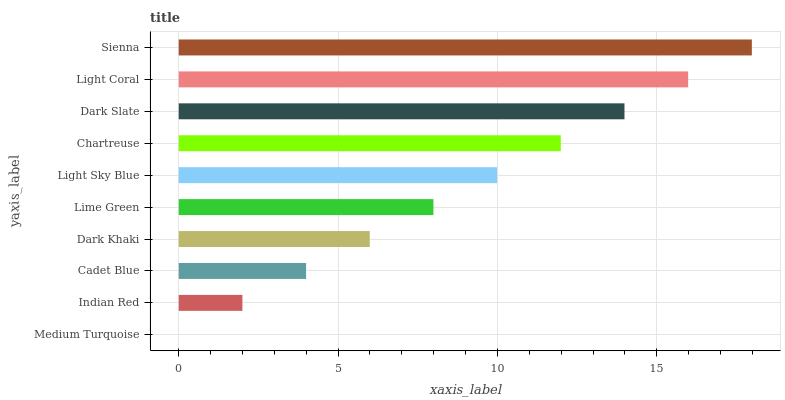Is Medium Turquoise the minimum?
Answer yes or no. Yes. Is Sienna the maximum?
Answer yes or no. Yes. Is Indian Red the minimum?
Answer yes or no. No. Is Indian Red the maximum?
Answer yes or no. No. Is Indian Red greater than Medium Turquoise?
Answer yes or no. Yes. Is Medium Turquoise less than Indian Red?
Answer yes or no. Yes. Is Medium Turquoise greater than Indian Red?
Answer yes or no. No. Is Indian Red less than Medium Turquoise?
Answer yes or no. No. Is Light Sky Blue the high median?
Answer yes or no. Yes. Is Lime Green the low median?
Answer yes or no. Yes. Is Dark Khaki the high median?
Answer yes or no. No. Is Indian Red the low median?
Answer yes or no. No. 